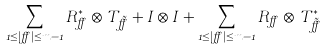<formula> <loc_0><loc_0><loc_500><loc_500>\sum _ { 1 \leq | \alpha | \leq m - 1 } R _ { \alpha } ^ { * } \otimes T _ { \tilde { \alpha } } + I \otimes I + \sum _ { 1 \leq | \alpha | \leq m - 1 } R _ { \alpha } \otimes T _ { \tilde { \alpha } } ^ { * }</formula> 